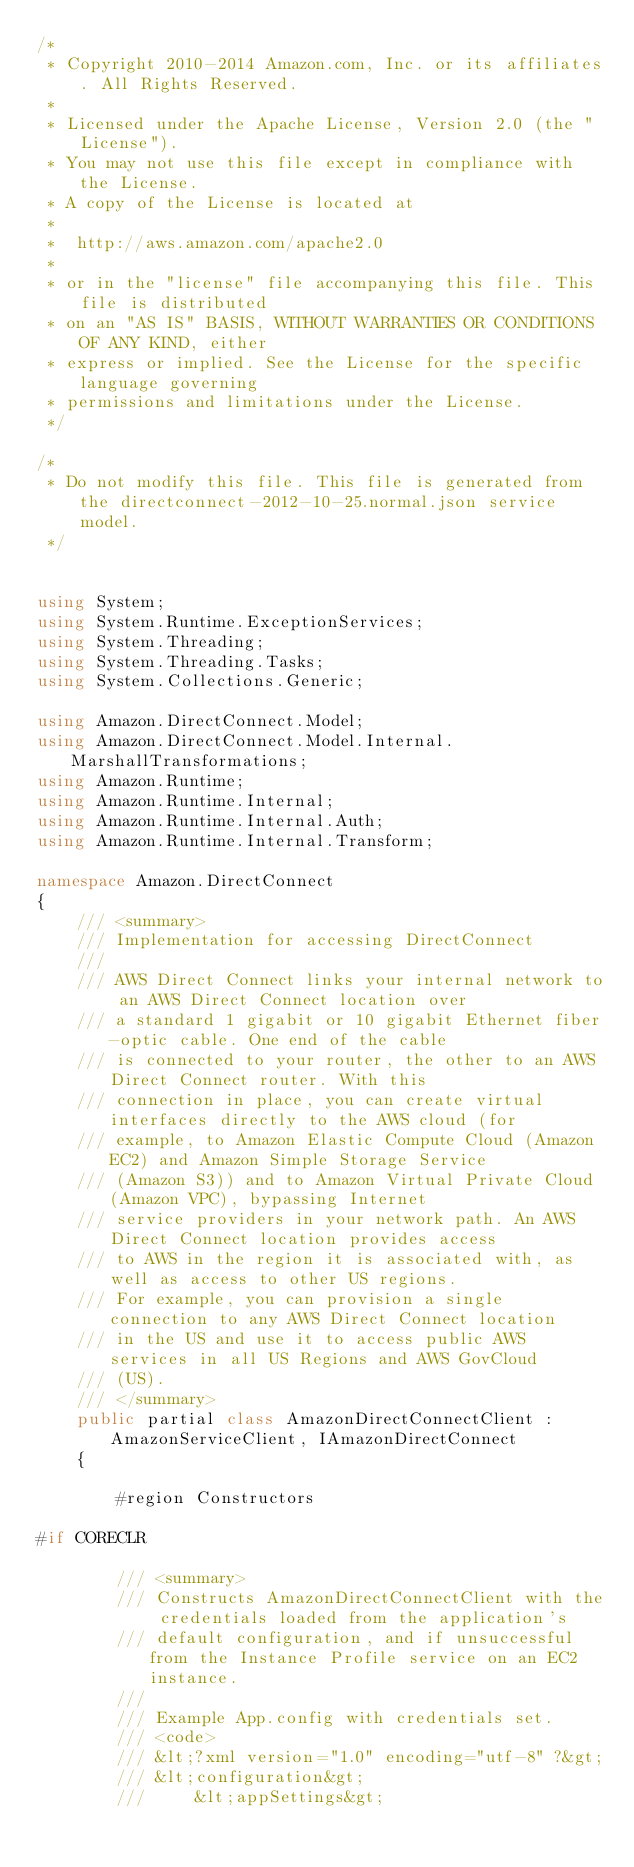Convert code to text. <code><loc_0><loc_0><loc_500><loc_500><_C#_>/*
 * Copyright 2010-2014 Amazon.com, Inc. or its affiliates. All Rights Reserved.
 * 
 * Licensed under the Apache License, Version 2.0 (the "License").
 * You may not use this file except in compliance with the License.
 * A copy of the License is located at
 * 
 *  http://aws.amazon.com/apache2.0
 * 
 * or in the "license" file accompanying this file. This file is distributed
 * on an "AS IS" BASIS, WITHOUT WARRANTIES OR CONDITIONS OF ANY KIND, either
 * express or implied. See the License for the specific language governing
 * permissions and limitations under the License.
 */

/*
 * Do not modify this file. This file is generated from the directconnect-2012-10-25.normal.json service model.
 */


using System;
using System.Runtime.ExceptionServices;
using System.Threading;
using System.Threading.Tasks;
using System.Collections.Generic;

using Amazon.DirectConnect.Model;
using Amazon.DirectConnect.Model.Internal.MarshallTransformations;
using Amazon.Runtime;
using Amazon.Runtime.Internal;
using Amazon.Runtime.Internal.Auth;
using Amazon.Runtime.Internal.Transform;

namespace Amazon.DirectConnect
{
    /// <summary>
    /// Implementation for accessing DirectConnect
    ///
    /// AWS Direct Connect links your internal network to an AWS Direct Connect location over
    /// a standard 1 gigabit or 10 gigabit Ethernet fiber-optic cable. One end of the cable
    /// is connected to your router, the other to an AWS Direct Connect router. With this
    /// connection in place, you can create virtual interfaces directly to the AWS cloud (for
    /// example, to Amazon Elastic Compute Cloud (Amazon EC2) and Amazon Simple Storage Service
    /// (Amazon S3)) and to Amazon Virtual Private Cloud (Amazon VPC), bypassing Internet
    /// service providers in your network path. An AWS Direct Connect location provides access
    /// to AWS in the region it is associated with, as well as access to other US regions.
    /// For example, you can provision a single connection to any AWS Direct Connect location
    /// in the US and use it to access public AWS services in all US Regions and AWS GovCloud
    /// (US).
    /// </summary>
    public partial class AmazonDirectConnectClient : AmazonServiceClient, IAmazonDirectConnect
    {
        
        #region Constructors

#if CORECLR
    
        /// <summary>
        /// Constructs AmazonDirectConnectClient with the credentials loaded from the application's
        /// default configuration, and if unsuccessful from the Instance Profile service on an EC2 instance.
        /// 
        /// Example App.config with credentials set. 
        /// <code>
        /// &lt;?xml version="1.0" encoding="utf-8" ?&gt;
        /// &lt;configuration&gt;
        ///     &lt;appSettings&gt;</code> 